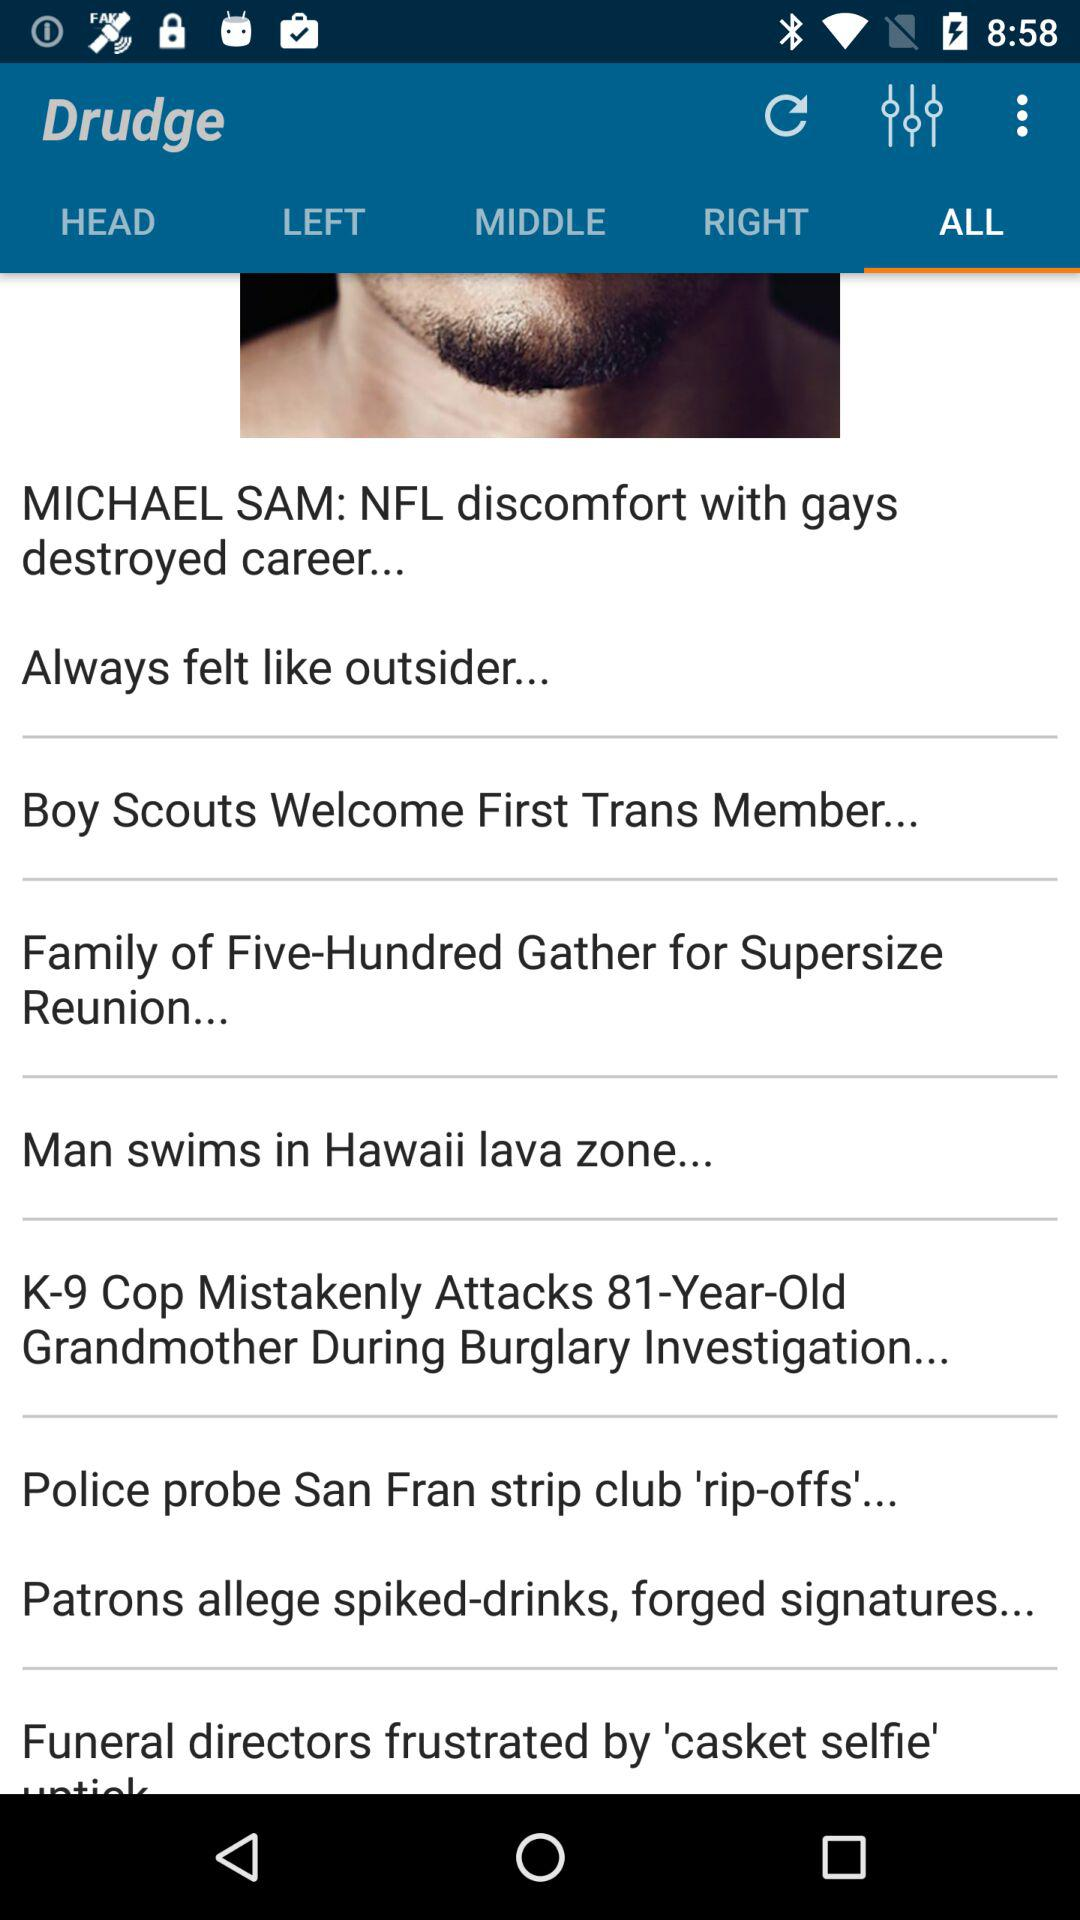Which tab is selected? The selected tab is "ALL". 